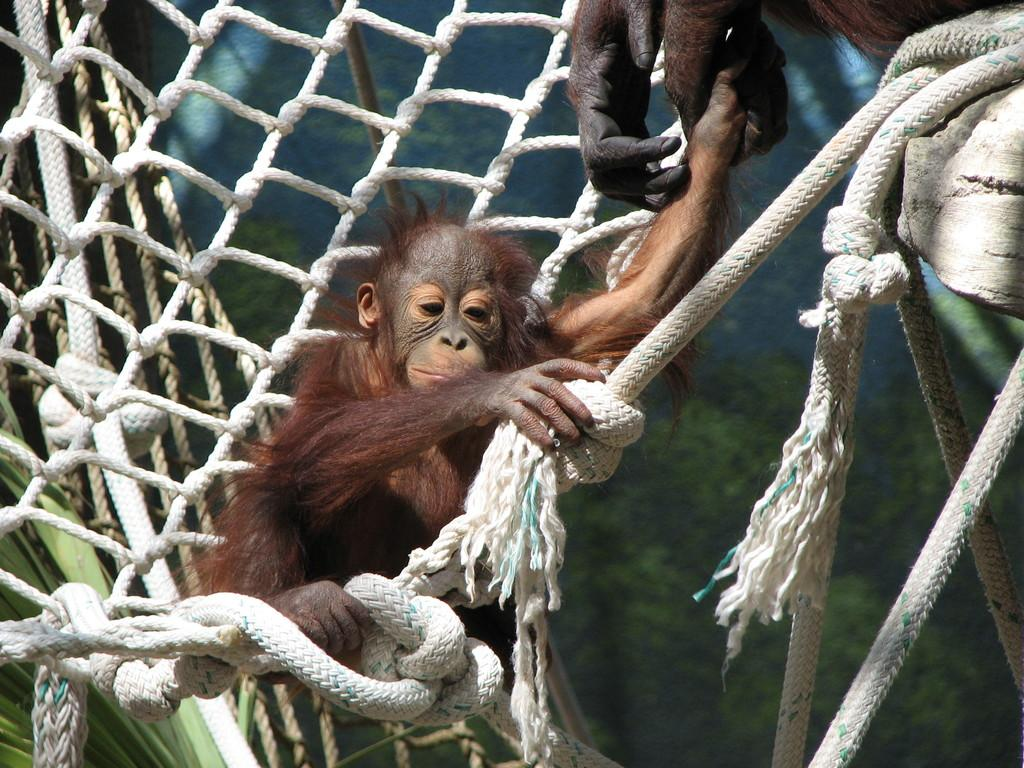What animal is present in the image? There is a monkey in the image. What is the monkey doing in the image? The monkey is sitting on a rope. What type of match is the monkey playing in the image? There is no match or baseball game present in the image; it only features a monkey sitting on a rope. 